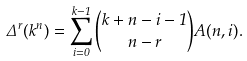<formula> <loc_0><loc_0><loc_500><loc_500>\Delta ^ { r } ( k ^ { n } ) = \sum _ { i = 0 } ^ { k - 1 } \binom { k + n - i - 1 } { n - r } A ( n , i ) .</formula> 